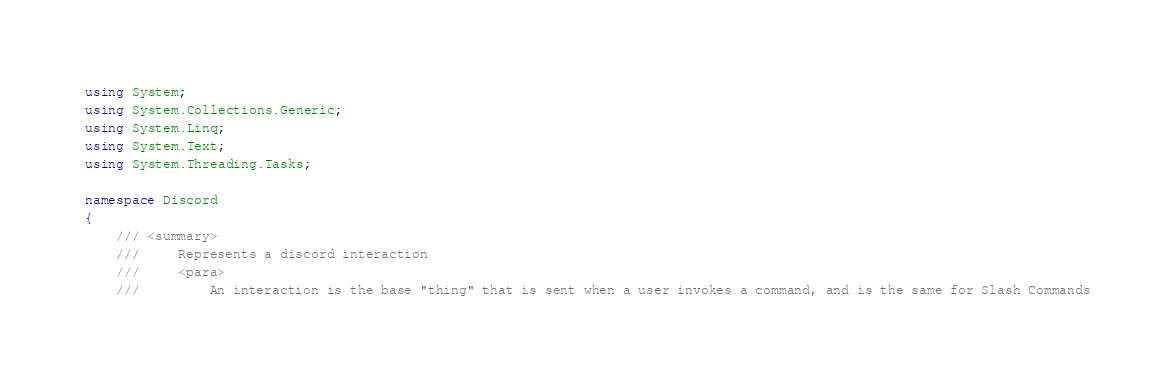<code> <loc_0><loc_0><loc_500><loc_500><_C#_>using System;
using System.Collections.Generic;
using System.Linq;
using System.Text;
using System.Threading.Tasks;

namespace Discord
{
    /// <summary>
    ///     Represents a discord interaction
    ///     <para>
    ///         An interaction is the base "thing" that is sent when a user invokes a command, and is the same for Slash Commands</code> 